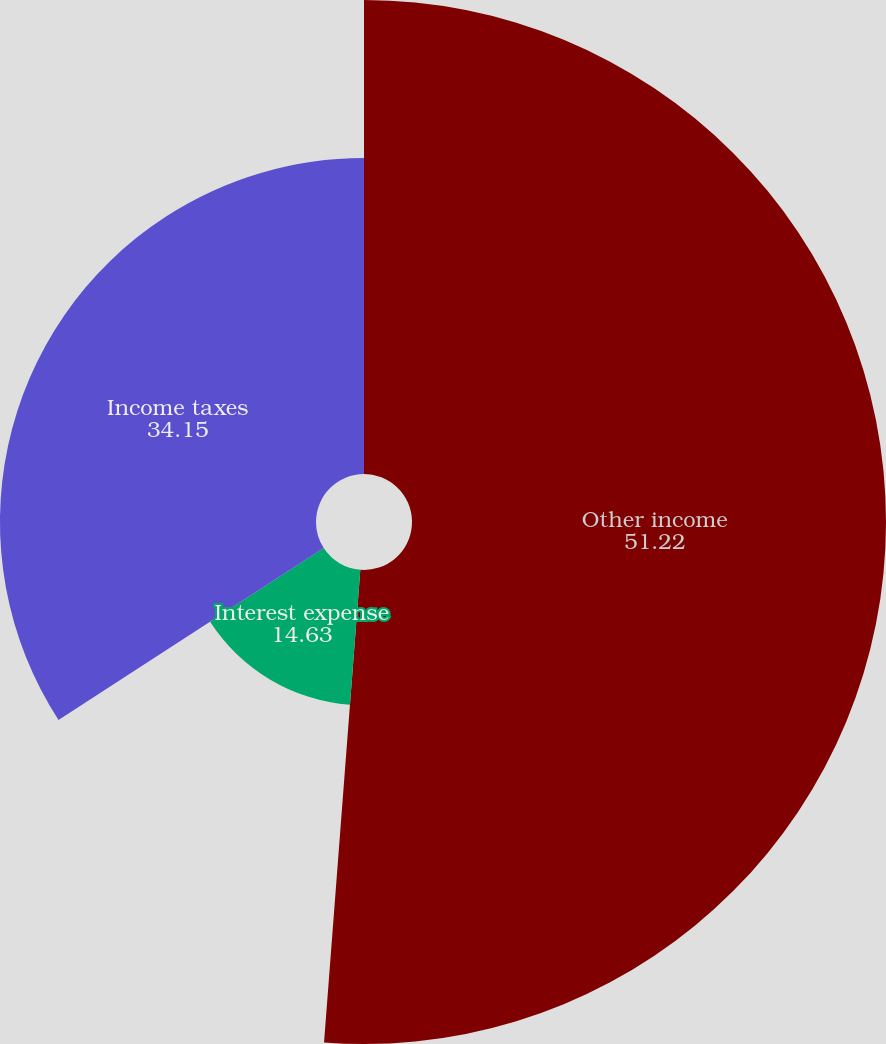<chart> <loc_0><loc_0><loc_500><loc_500><pie_chart><fcel>Other income<fcel>Interest expense<fcel>Income taxes<nl><fcel>51.22%<fcel>14.63%<fcel>34.15%<nl></chart> 